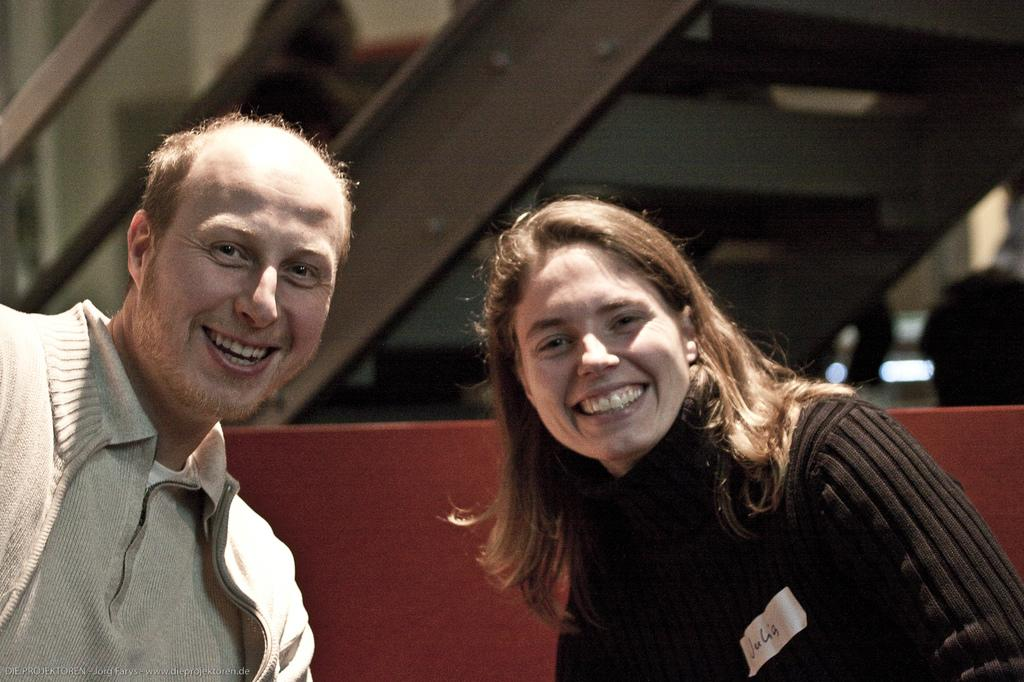How many people are in the image? There are two people in the image. What expressions do the people have? The people are smiling. Can you describe the background of the image? The background is blurry, and there are steps and a railing visible. What type of shade is being provided by the jellyfish in the image? There are no jellyfish present in the image, so no shade is being provided by them. 